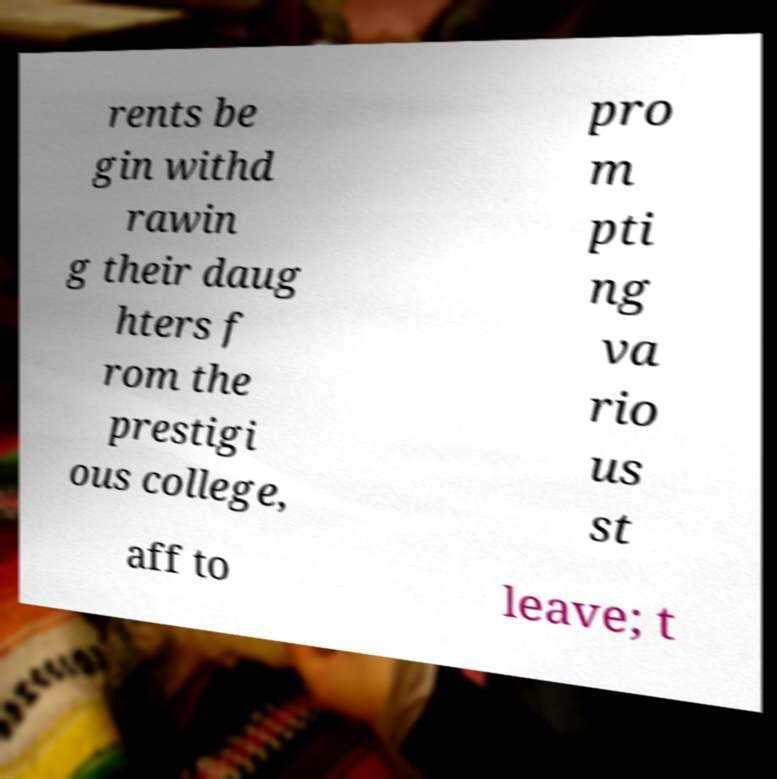Could you extract and type out the text from this image? rents be gin withd rawin g their daug hters f rom the prestigi ous college, pro m pti ng va rio us st aff to leave; t 